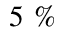<formula> <loc_0><loc_0><loc_500><loc_500>5 \ \%</formula> 